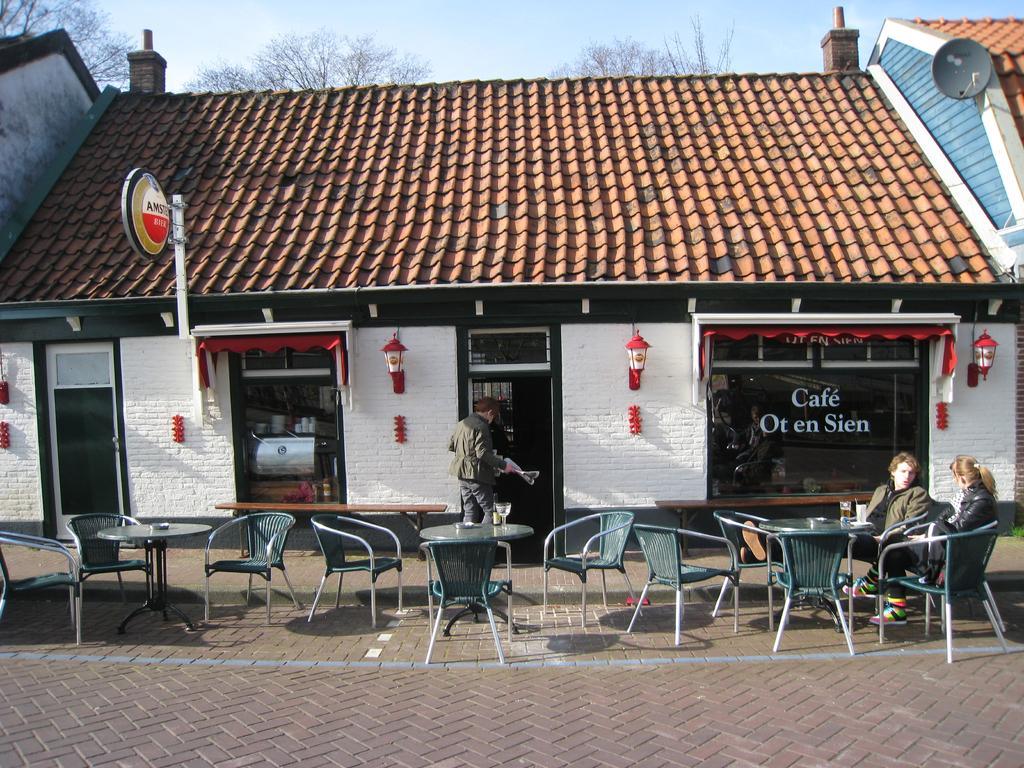Could you give a brief overview of what you see in this image? in this image there are chairs and tables on the sidewalk. at the right people are sitting on the chairs. behind them there is a building and a roof. the building contains a glass door. in front of that there is a person standing. the building is named as cafe ot en sien 